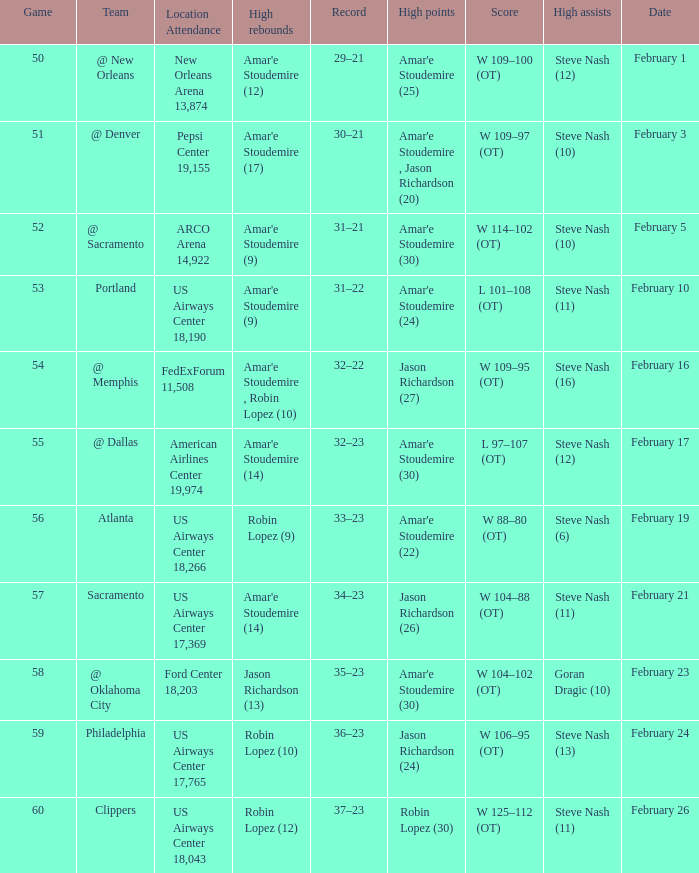Name the date for score w 109–95 (ot) February 16. 